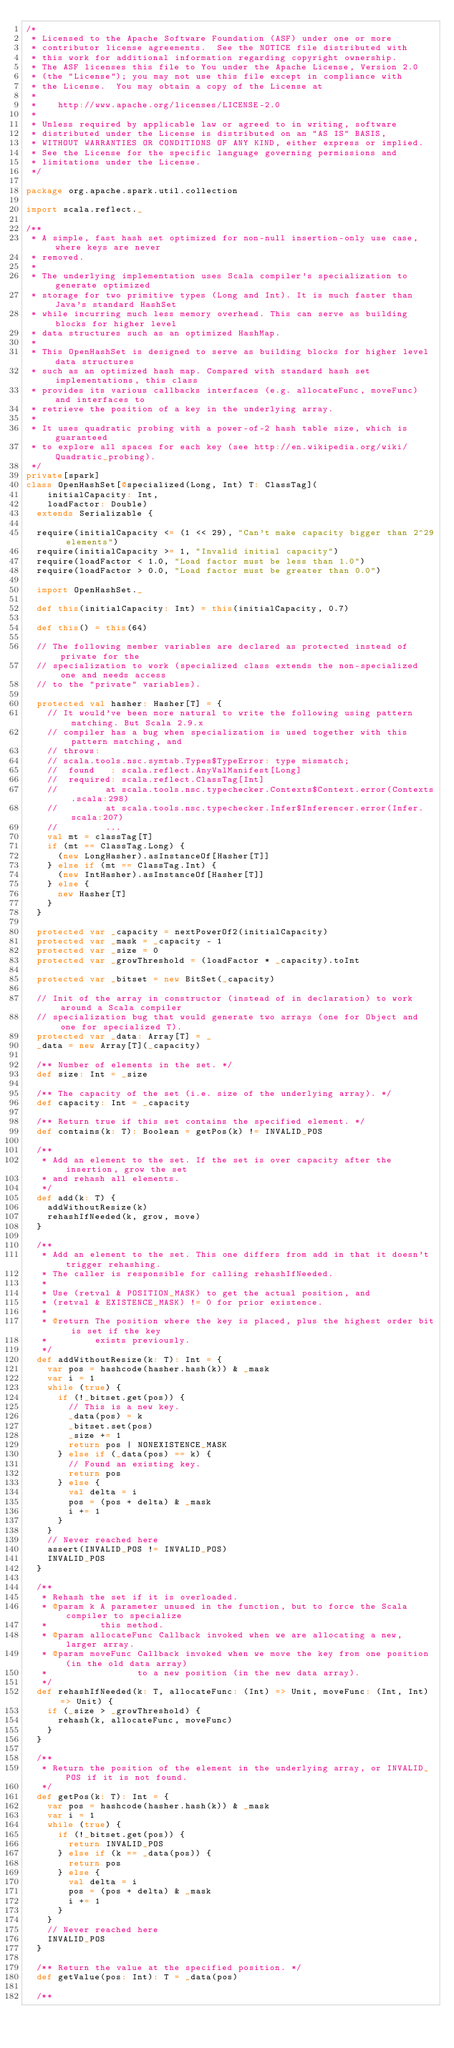<code> <loc_0><loc_0><loc_500><loc_500><_Scala_>/*
 * Licensed to the Apache Software Foundation (ASF) under one or more
 * contributor license agreements.  See the NOTICE file distributed with
 * this work for additional information regarding copyright ownership.
 * The ASF licenses this file to You under the Apache License, Version 2.0
 * (the "License"); you may not use this file except in compliance with
 * the License.  You may obtain a copy of the License at
 *
 *    http://www.apache.org/licenses/LICENSE-2.0
 *
 * Unless required by applicable law or agreed to in writing, software
 * distributed under the License is distributed on an "AS IS" BASIS,
 * WITHOUT WARRANTIES OR CONDITIONS OF ANY KIND, either express or implied.
 * See the License for the specific language governing permissions and
 * limitations under the License.
 */

package org.apache.spark.util.collection

import scala.reflect._

/**
 * A simple, fast hash set optimized for non-null insertion-only use case, where keys are never
 * removed.
 *
 * The underlying implementation uses Scala compiler's specialization to generate optimized
 * storage for two primitive types (Long and Int). It is much faster than Java's standard HashSet
 * while incurring much less memory overhead. This can serve as building blocks for higher level
 * data structures such as an optimized HashMap.
 *
 * This OpenHashSet is designed to serve as building blocks for higher level data structures
 * such as an optimized hash map. Compared with standard hash set implementations, this class
 * provides its various callbacks interfaces (e.g. allocateFunc, moveFunc) and interfaces to
 * retrieve the position of a key in the underlying array.
 *
 * It uses quadratic probing with a power-of-2 hash table size, which is guaranteed
 * to explore all spaces for each key (see http://en.wikipedia.org/wiki/Quadratic_probing).
 */
private[spark]
class OpenHashSet[@specialized(Long, Int) T: ClassTag](
    initialCapacity: Int,
    loadFactor: Double)
  extends Serializable {

  require(initialCapacity <= (1 << 29), "Can't make capacity bigger than 2^29 elements")
  require(initialCapacity >= 1, "Invalid initial capacity")
  require(loadFactor < 1.0, "Load factor must be less than 1.0")
  require(loadFactor > 0.0, "Load factor must be greater than 0.0")

  import OpenHashSet._

  def this(initialCapacity: Int) = this(initialCapacity, 0.7)

  def this() = this(64)

  // The following member variables are declared as protected instead of private for the
  // specialization to work (specialized class extends the non-specialized one and needs access
  // to the "private" variables).

  protected val hasher: Hasher[T] = {
    // It would've been more natural to write the following using pattern matching. But Scala 2.9.x
    // compiler has a bug when specialization is used together with this pattern matching, and
    // throws:
    // scala.tools.nsc.symtab.Types$TypeError: type mismatch;
    //  found   : scala.reflect.AnyValManifest[Long]
    //  required: scala.reflect.ClassTag[Int]
    //         at scala.tools.nsc.typechecker.Contexts$Context.error(Contexts.scala:298)
    //         at scala.tools.nsc.typechecker.Infer$Inferencer.error(Infer.scala:207)
    //         ...
    val mt = classTag[T]
    if (mt == ClassTag.Long) {
      (new LongHasher).asInstanceOf[Hasher[T]]
    } else if (mt == ClassTag.Int) {
      (new IntHasher).asInstanceOf[Hasher[T]]
    } else {
      new Hasher[T]
    }
  }

  protected var _capacity = nextPowerOf2(initialCapacity)
  protected var _mask = _capacity - 1
  protected var _size = 0
  protected var _growThreshold = (loadFactor * _capacity).toInt

  protected var _bitset = new BitSet(_capacity)

  // Init of the array in constructor (instead of in declaration) to work around a Scala compiler
  // specialization bug that would generate two arrays (one for Object and one for specialized T).
  protected var _data: Array[T] = _
  _data = new Array[T](_capacity)

  /** Number of elements in the set. */
  def size: Int = _size

  /** The capacity of the set (i.e. size of the underlying array). */
  def capacity: Int = _capacity

  /** Return true if this set contains the specified element. */
  def contains(k: T): Boolean = getPos(k) != INVALID_POS

  /**
   * Add an element to the set. If the set is over capacity after the insertion, grow the set
   * and rehash all elements.
   */
  def add(k: T) {
    addWithoutResize(k)
    rehashIfNeeded(k, grow, move)
  }

  /**
   * Add an element to the set. This one differs from add in that it doesn't trigger rehashing.
   * The caller is responsible for calling rehashIfNeeded.
   *
   * Use (retval & POSITION_MASK) to get the actual position, and
   * (retval & EXISTENCE_MASK) != 0 for prior existence.
   *
   * @return The position where the key is placed, plus the highest order bit is set if the key
   *         exists previously.
   */
  def addWithoutResize(k: T): Int = {
    var pos = hashcode(hasher.hash(k)) & _mask
    var i = 1
    while (true) {
      if (!_bitset.get(pos)) {
        // This is a new key.
        _data(pos) = k
        _bitset.set(pos)
        _size += 1
        return pos | NONEXISTENCE_MASK
      } else if (_data(pos) == k) {
        // Found an existing key.
        return pos
      } else {
        val delta = i
        pos = (pos + delta) & _mask
        i += 1
      }
    }
    // Never reached here
    assert(INVALID_POS != INVALID_POS)
    INVALID_POS
  }

  /**
   * Rehash the set if it is overloaded.
   * @param k A parameter unused in the function, but to force the Scala compiler to specialize
   *          this method.
   * @param allocateFunc Callback invoked when we are allocating a new, larger array.
   * @param moveFunc Callback invoked when we move the key from one position (in the old data array)
   *                 to a new position (in the new data array).
   */
  def rehashIfNeeded(k: T, allocateFunc: (Int) => Unit, moveFunc: (Int, Int) => Unit) {
    if (_size > _growThreshold) {
      rehash(k, allocateFunc, moveFunc)
    }
  }

  /**
   * Return the position of the element in the underlying array, or INVALID_POS if it is not found.
   */
  def getPos(k: T): Int = {
    var pos = hashcode(hasher.hash(k)) & _mask
    var i = 1
    while (true) {
      if (!_bitset.get(pos)) {
        return INVALID_POS
      } else if (k == _data(pos)) {
        return pos
      } else {
        val delta = i
        pos = (pos + delta) & _mask
        i += 1
      }
    }
    // Never reached here
    INVALID_POS
  }

  /** Return the value at the specified position. */
  def getValue(pos: Int): T = _data(pos)

  /**</code> 